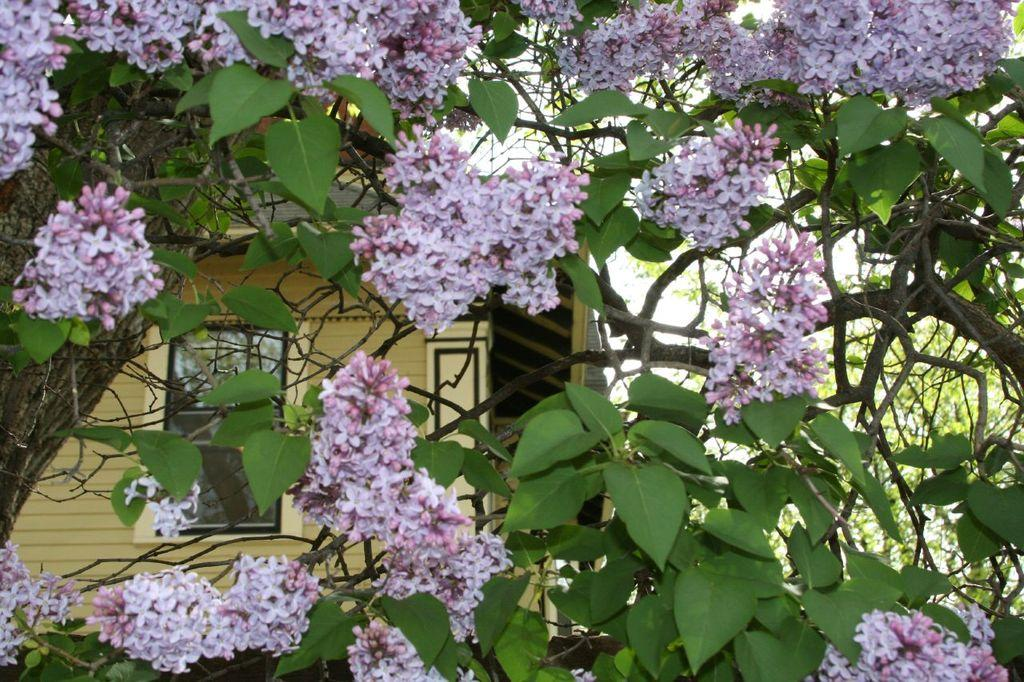What types of plants are in the foreground of the image? There are trees and flowers in the foreground of the image. What can be seen in the background of the image? There is a building and trees in the background of the image. What type of brass instrument is being played in the image? There is no brass instrument present in the image; it features trees, flowers, a building, and additional trees. Can you tell me the time of day the receipt was issued in the image? There is no receipt present in the image, so it is not possible to determine the time of day it was issued. 